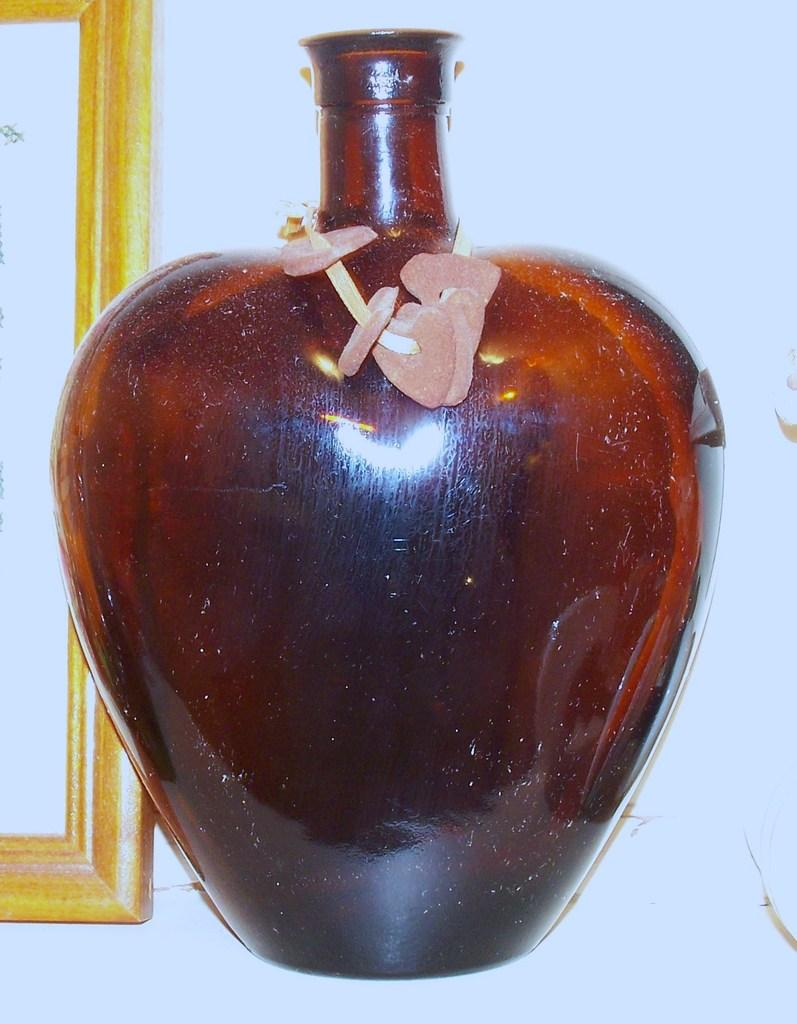What is located in the middle of the image? There is a glass bottle in the middle of the image. What can be seen on the left side of the image? There is a frame on the left side of the image. What is on the glass bottle? There are flowers on the glass bottle. What type of sack is being carried by the servant in the image? There is no servant or sack present in the image. What role does the cast play in the image? There is no cast or theatrical performance depicted in the image. 